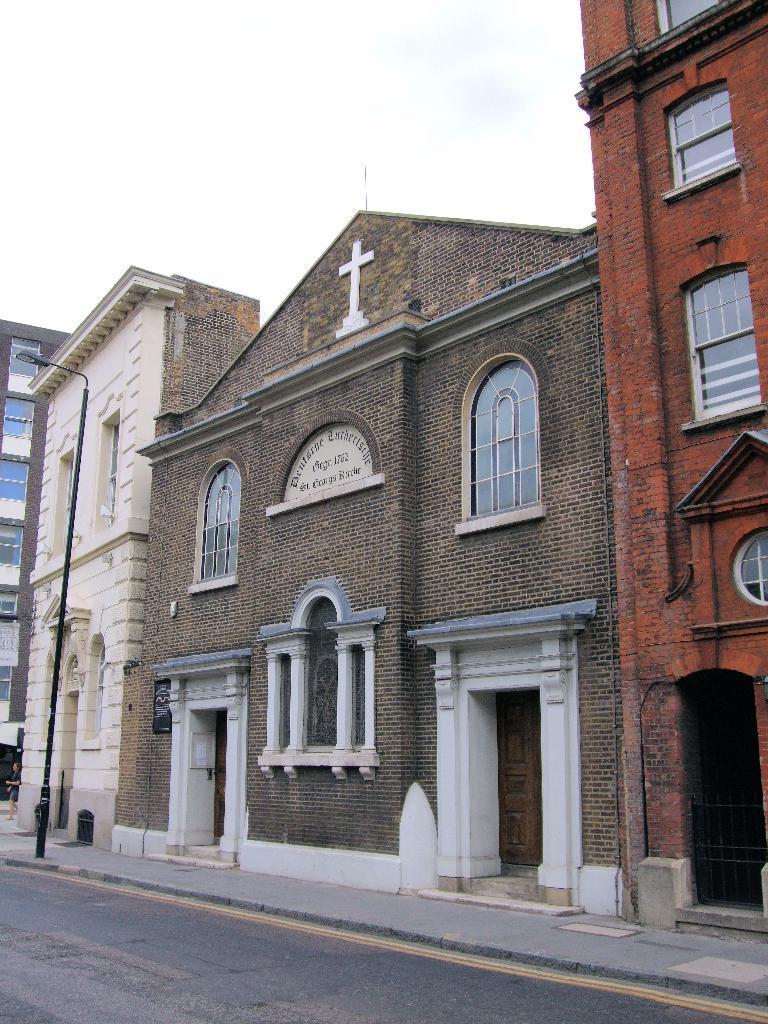How would you summarize this image in a sentence or two? In the picture I can see the buildings on the side of the road. I can see the glass windows of the buildings. I can see a wooden door of a house. I can see the metal grill fence on the bottom right side. I can see a light pole on the side of the road. There are clouds in the sky. I can see a person on the bottom left side of the picture. 